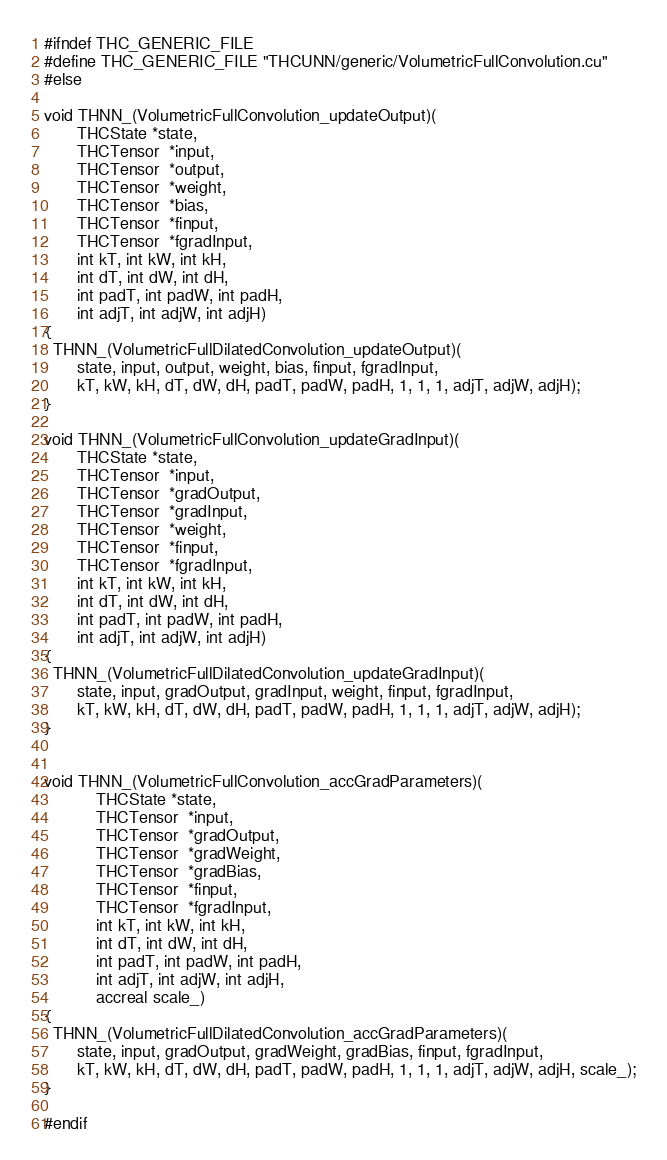Convert code to text. <code><loc_0><loc_0><loc_500><loc_500><_Cuda_>#ifndef THC_GENERIC_FILE
#define THC_GENERIC_FILE "THCUNN/generic/VolumetricFullConvolution.cu"
#else

void THNN_(VolumetricFullConvolution_updateOutput)(
       THCState *state,
       THCTensor  *input,
       THCTensor  *output,
       THCTensor  *weight,
       THCTensor  *bias,
       THCTensor  *finput,
       THCTensor  *fgradInput,
       int kT, int kW, int kH,
       int dT, int dW, int dH,
       int padT, int padW, int padH,
       int adjT, int adjW, int adjH)
{
  THNN_(VolumetricFullDilatedConvolution_updateOutput)(
       state, input, output, weight, bias, finput, fgradInput,
       kT, kW, kH, dT, dW, dH, padT, padW, padH, 1, 1, 1, adjT, adjW, adjH);
}

void THNN_(VolumetricFullConvolution_updateGradInput)(
       THCState *state,
       THCTensor  *input,
       THCTensor  *gradOutput,
       THCTensor  *gradInput,
       THCTensor  *weight,
       THCTensor  *finput,
       THCTensor  *fgradInput,
       int kT, int kW, int kH,
       int dT, int dW, int dH,
       int padT, int padW, int padH,
       int adjT, int adjW, int adjH)
{
  THNN_(VolumetricFullDilatedConvolution_updateGradInput)(
       state, input, gradOutput, gradInput, weight, finput, fgradInput,
       kT, kW, kH, dT, dW, dH, padT, padW, padH, 1, 1, 1, adjT, adjW, adjH);
}


void THNN_(VolumetricFullConvolution_accGradParameters)(
           THCState *state,
           THCTensor  *input,
           THCTensor  *gradOutput,
           THCTensor  *gradWeight,
           THCTensor  *gradBias,
           THCTensor  *finput,
           THCTensor  *fgradInput,
           int kT, int kW, int kH,
           int dT, int dW, int dH,
           int padT, int padW, int padH,
           int adjT, int adjW, int adjH,
           accreal scale_)
{
  THNN_(VolumetricFullDilatedConvolution_accGradParameters)(
       state, input, gradOutput, gradWeight, gradBias, finput, fgradInput,
       kT, kW, kH, dT, dW, dH, padT, padW, padH, 1, 1, 1, adjT, adjW, adjH, scale_);
}

#endif
</code> 